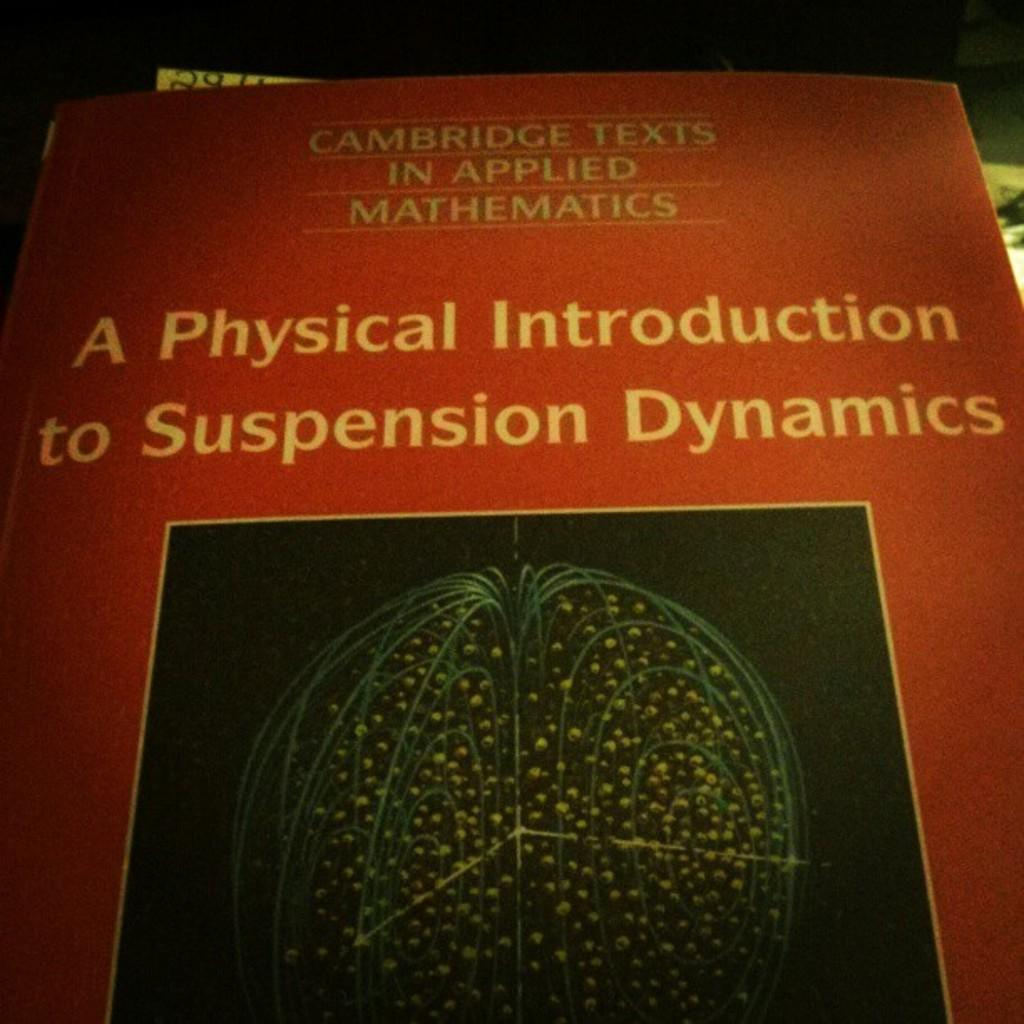<image>
Summarize the visual content of the image. The front page of a book titled, A Physical Introduction to Suspension Dynamics. 